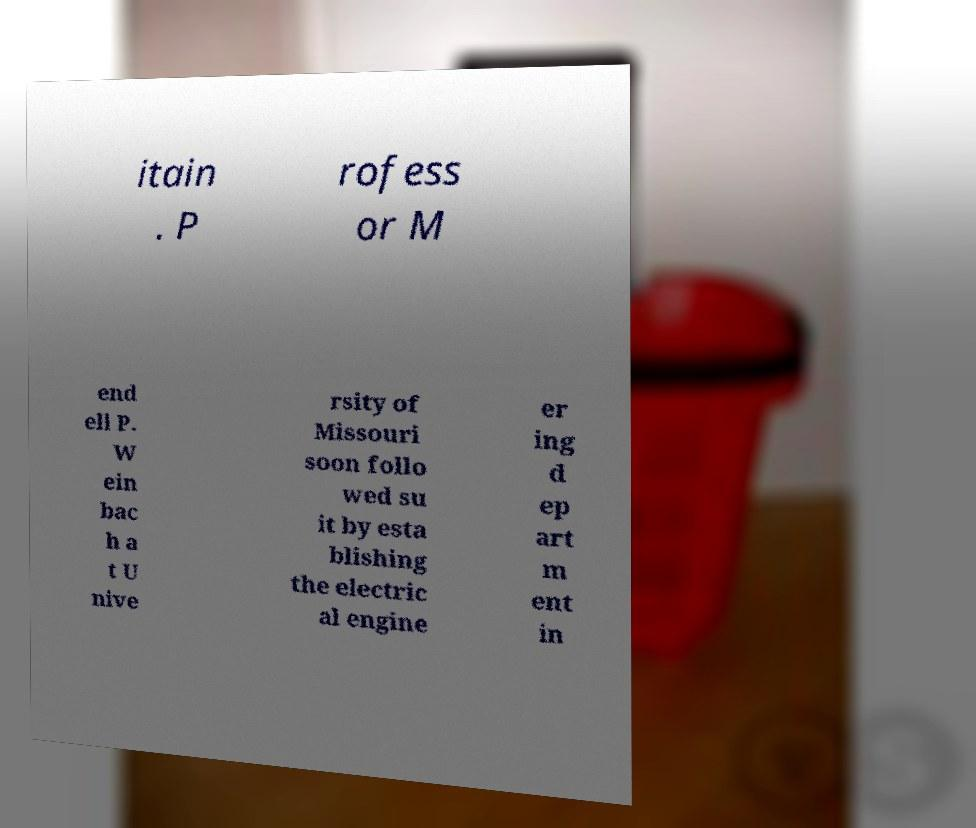Can you accurately transcribe the text from the provided image for me? itain . P rofess or M end ell P. W ein bac h a t U nive rsity of Missouri soon follo wed su it by esta blishing the electric al engine er ing d ep art m ent in 